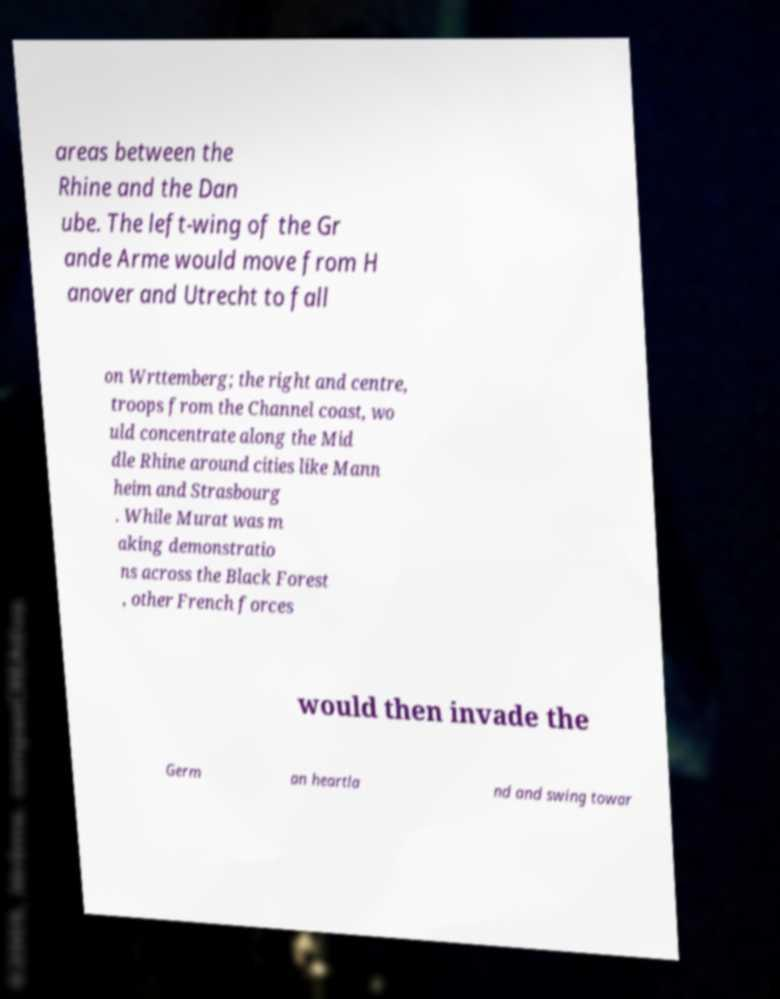Can you read and provide the text displayed in the image?This photo seems to have some interesting text. Can you extract and type it out for me? areas between the Rhine and the Dan ube. The left-wing of the Gr ande Arme would move from H anover and Utrecht to fall on Wrttemberg; the right and centre, troops from the Channel coast, wo uld concentrate along the Mid dle Rhine around cities like Mann heim and Strasbourg . While Murat was m aking demonstratio ns across the Black Forest , other French forces would then invade the Germ an heartla nd and swing towar 